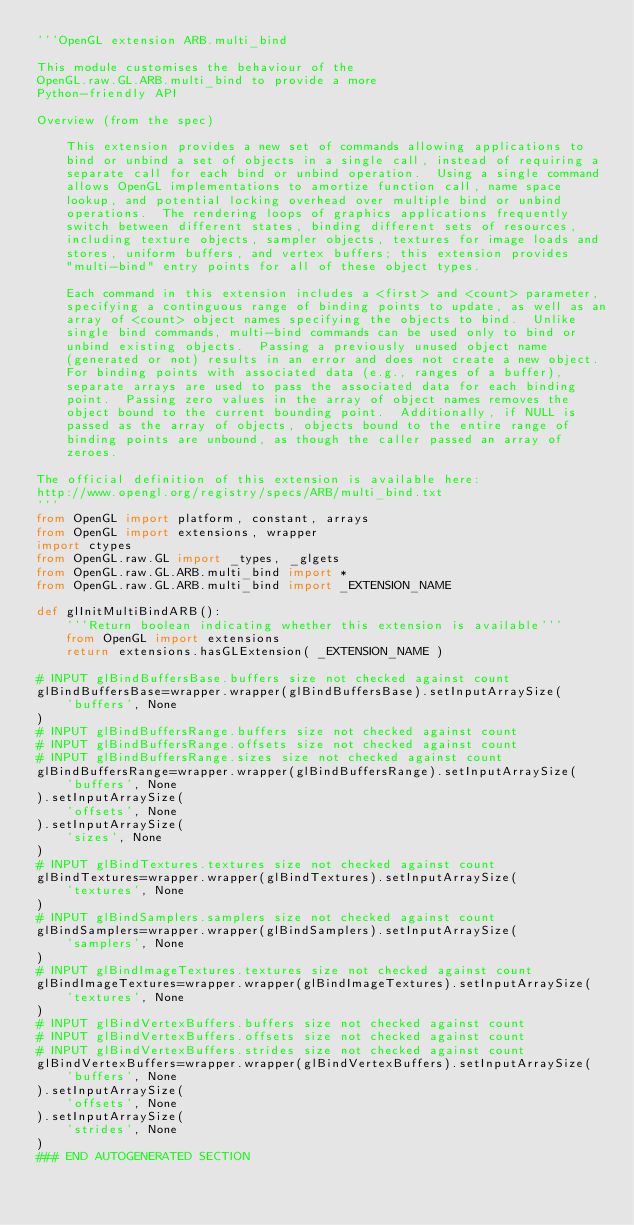<code> <loc_0><loc_0><loc_500><loc_500><_Python_>'''OpenGL extension ARB.multi_bind

This module customises the behaviour of the 
OpenGL.raw.GL.ARB.multi_bind to provide a more 
Python-friendly API

Overview (from the spec)
	
	This extension provides a new set of commands allowing applications to
	bind or unbind a set of objects in a single call, instead of requiring a
	separate call for each bind or unbind operation.  Using a single command
	allows OpenGL implementations to amortize function call, name space
	lookup, and potential locking overhead over multiple bind or unbind
	operations.  The rendering loops of graphics applications frequently
	switch between different states, binding different sets of resources,
	including texture objects, sampler objects, textures for image loads and
	stores, uniform buffers, and vertex buffers; this extension provides
	"multi-bind" entry points for all of these object types.
	
	Each command in this extension includes a <first> and <count> parameter,
	specifying a continguous range of binding points to update, as well as an
	array of <count> object names specifying the objects to bind.  Unlike
	single bind commands, multi-bind commands can be used only to bind or
	unbind existing objects.  Passing a previously unused object name
	(generated or not) results in an error and does not create a new object.
	For binding points with associated data (e.g., ranges of a buffer),
	separate arrays are used to pass the associated data for each binding
	point.  Passing zero values in the array of object names removes the
	object bound to the current bounding point.  Additionally, if NULL is
	passed as the array of objects, objects bound to the entire range of
	binding points are unbound, as though the caller passed an array of
	zeroes.

The official definition of this extension is available here:
http://www.opengl.org/registry/specs/ARB/multi_bind.txt
'''
from OpenGL import platform, constant, arrays
from OpenGL import extensions, wrapper
import ctypes
from OpenGL.raw.GL import _types, _glgets
from OpenGL.raw.GL.ARB.multi_bind import *
from OpenGL.raw.GL.ARB.multi_bind import _EXTENSION_NAME

def glInitMultiBindARB():
    '''Return boolean indicating whether this extension is available'''
    from OpenGL import extensions
    return extensions.hasGLExtension( _EXTENSION_NAME )

# INPUT glBindBuffersBase.buffers size not checked against count
glBindBuffersBase=wrapper.wrapper(glBindBuffersBase).setInputArraySize(
    'buffers', None
)
# INPUT glBindBuffersRange.buffers size not checked against count
# INPUT glBindBuffersRange.offsets size not checked against count
# INPUT glBindBuffersRange.sizes size not checked against count
glBindBuffersRange=wrapper.wrapper(glBindBuffersRange).setInputArraySize(
    'buffers', None
).setInputArraySize(
    'offsets', None
).setInputArraySize(
    'sizes', None
)
# INPUT glBindTextures.textures size not checked against count
glBindTextures=wrapper.wrapper(glBindTextures).setInputArraySize(
    'textures', None
)
# INPUT glBindSamplers.samplers size not checked against count
glBindSamplers=wrapper.wrapper(glBindSamplers).setInputArraySize(
    'samplers', None
)
# INPUT glBindImageTextures.textures size not checked against count
glBindImageTextures=wrapper.wrapper(glBindImageTextures).setInputArraySize(
    'textures', None
)
# INPUT glBindVertexBuffers.buffers size not checked against count
# INPUT glBindVertexBuffers.offsets size not checked against count
# INPUT glBindVertexBuffers.strides size not checked against count
glBindVertexBuffers=wrapper.wrapper(glBindVertexBuffers).setInputArraySize(
    'buffers', None
).setInputArraySize(
    'offsets', None
).setInputArraySize(
    'strides', None
)
### END AUTOGENERATED SECTION</code> 